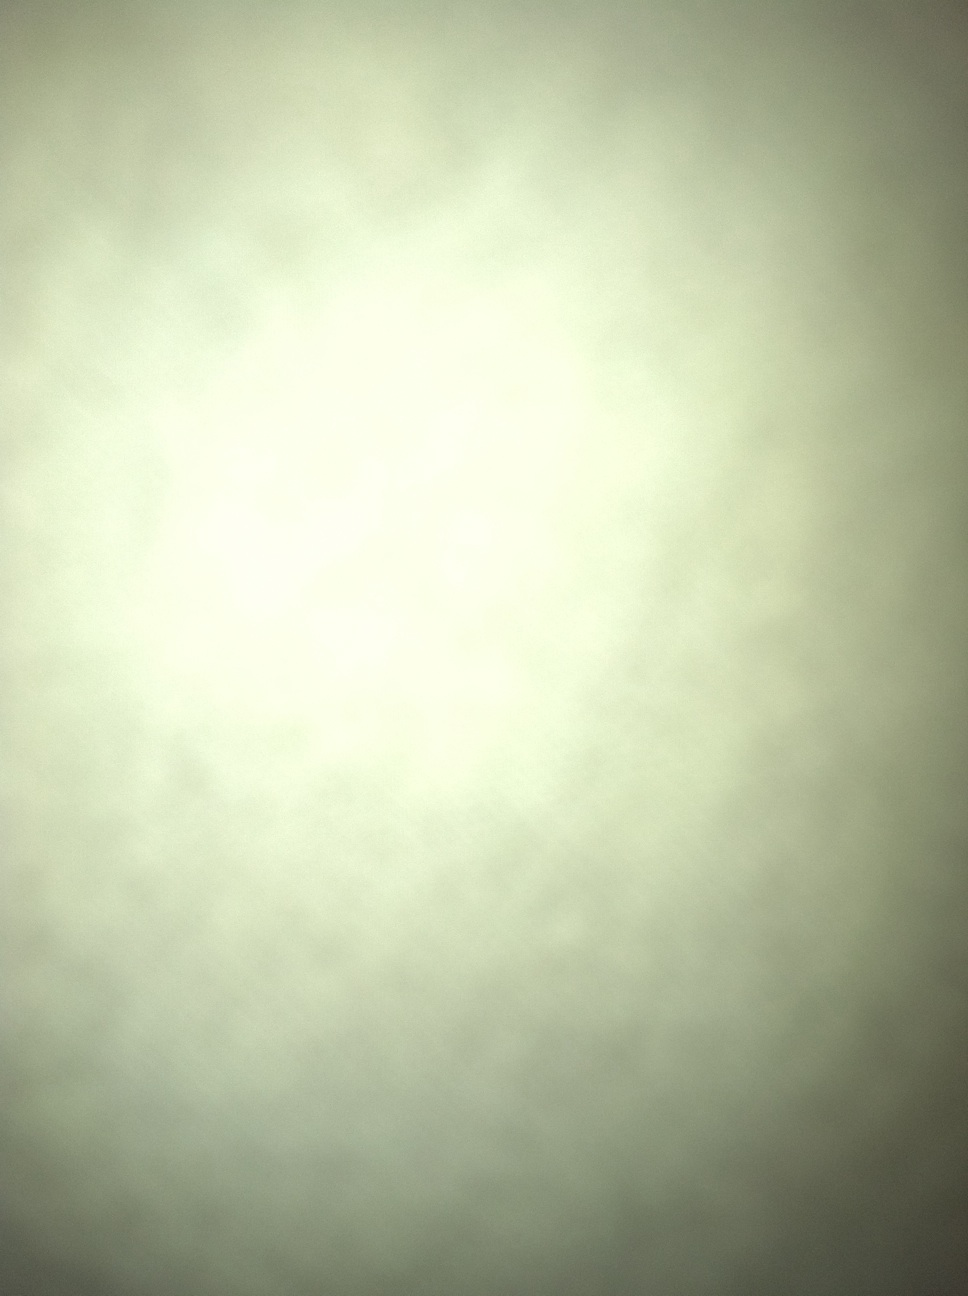Can you tell me the color of this shirt? I'm sorry, but the image doesn't show a shirt clearly enough to determine its color. It appears to be a blurred or unfocused image. 